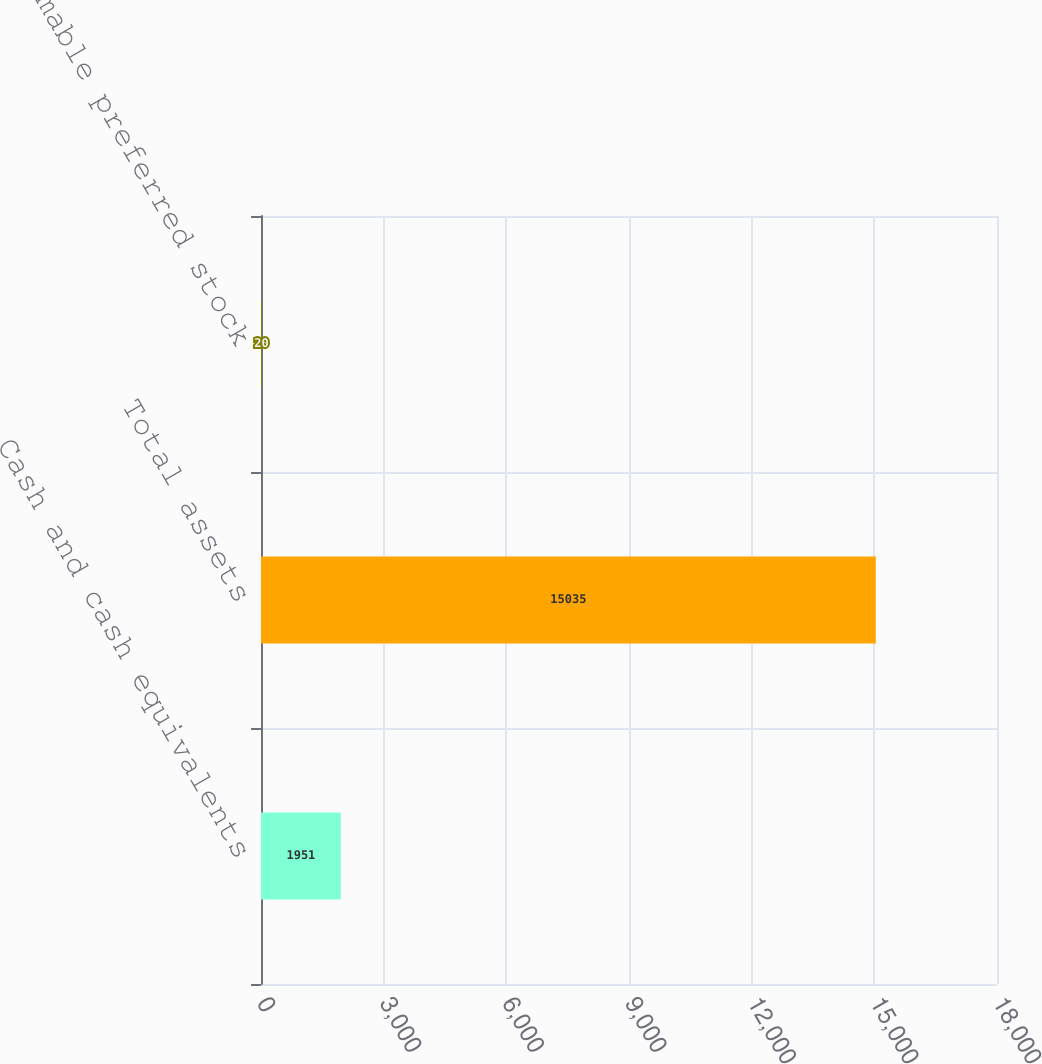Convert chart. <chart><loc_0><loc_0><loc_500><loc_500><bar_chart><fcel>Cash and cash equivalents<fcel>Total assets<fcel>Redeemable preferred stock<nl><fcel>1951<fcel>15035<fcel>20<nl></chart> 